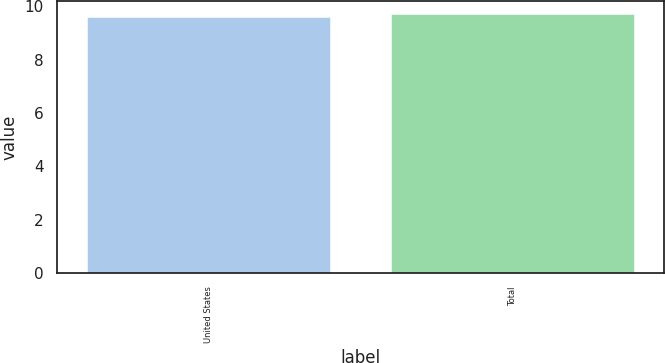<chart> <loc_0><loc_0><loc_500><loc_500><bar_chart><fcel>United States<fcel>Total<nl><fcel>9.6<fcel>9.7<nl></chart> 